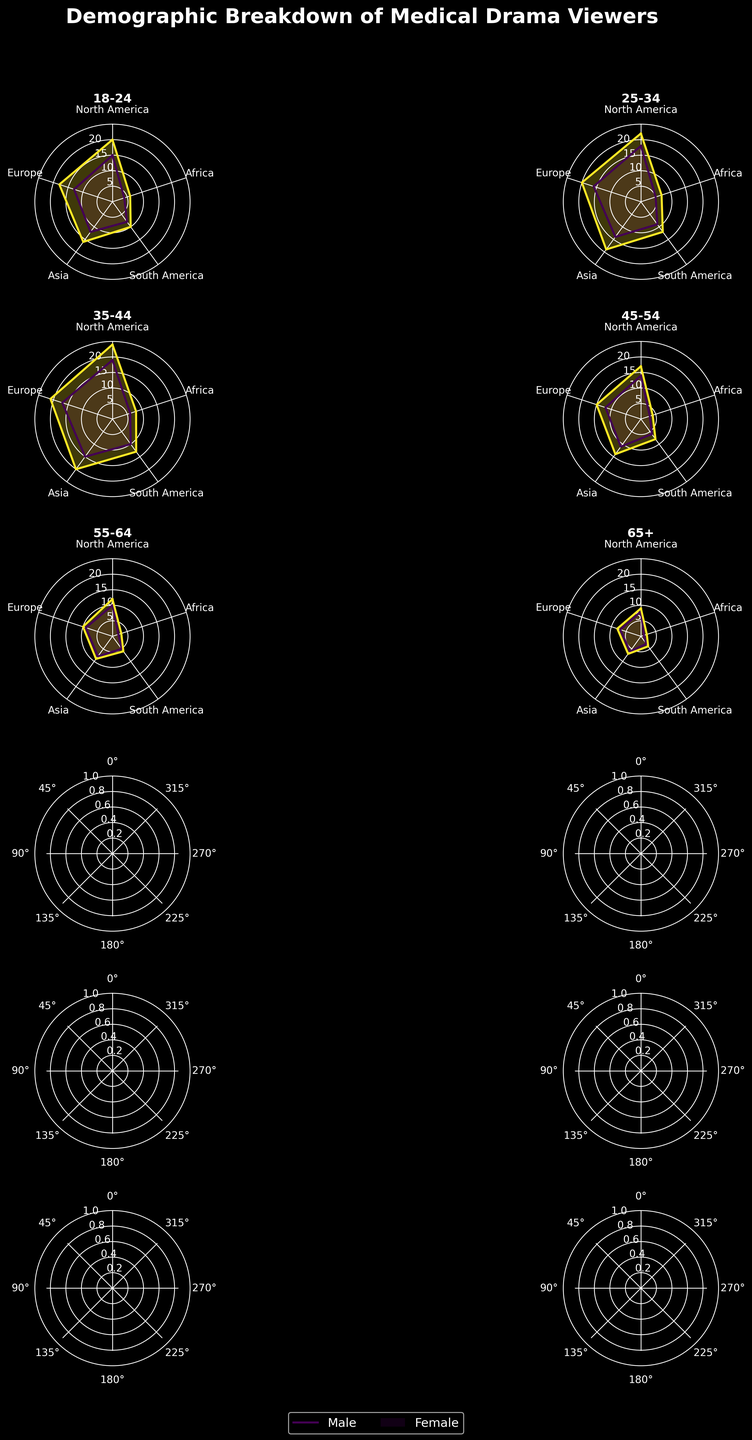what is the central theme of the figure? The title of the figure reads "Demographic Breakdown of Medical Drama Viewers," which indicates that the central theme is to show the audience distribution based on age, gender, and geographical regions.
Answer: Demographic Breakdown of Medical Drama Viewers which age group has the highest viewership in North America for males? To find this, examine the radar charts for male viewers in different age groups. The 35-44 male age group shows the highest point on the North America axis at 19 units.
Answer: 35-44 how many regions are represented in each radar chart? Count the number of distinct axes on any radar chart. There are five axes for five regions: North America, Europe, Asia, South America, and Africa.
Answer: 5 which gender has consistently higher viewership across all age groups in Europe? Compare the heights of the radar chart points for both genders in the Europe region across all age groups. In each case, females have higher values than males.
Answer: Female what is the average viewership for the 25-34 age group in Asia for both genders? The male viewership is 14, and the female viewership is 19 in Asia for the 25-34 age group. The average is calculated as (14 + 19) / 2 = 16.5.
Answer: 16.5 which region shows the least viewership for the 65+ age group, and what are the values? Examine the 65+ age group charts for both genders. The lowest points are in Africa at 1 for males and 2 for females.
Answer: Africa; 1 for males, 2 for females what is the difference in viewership between males and females aged 45-54 in South America? For the 45-54 age group in South America, males have 6 units, and females have 8 units. The difference is calculated as 8 - 6 = 2.
Answer: 2 does any gender have equal viewership in at least one region across different age groups? Examine each radar chart for both gender groups and check for equal values along any axis. In the 55-64 age group, females have equal viewership in South America and Africa, with 6 and 3 units, respectively.
Answer: Yes what is the trend in male viewership in Africa as age increases? Follow the male radar chart points for the Africa region across all age groups. The values decrease as age increases: 4, 5, 6, 3, 2, 1.
Answer: Decreasing which age group and gender combination has the highest viewership in Asia? Examine the radar chart points for Asia across all age groups and both genders. The highest value is 20 for females aged 35-44.
Answer: 35-44 Females 